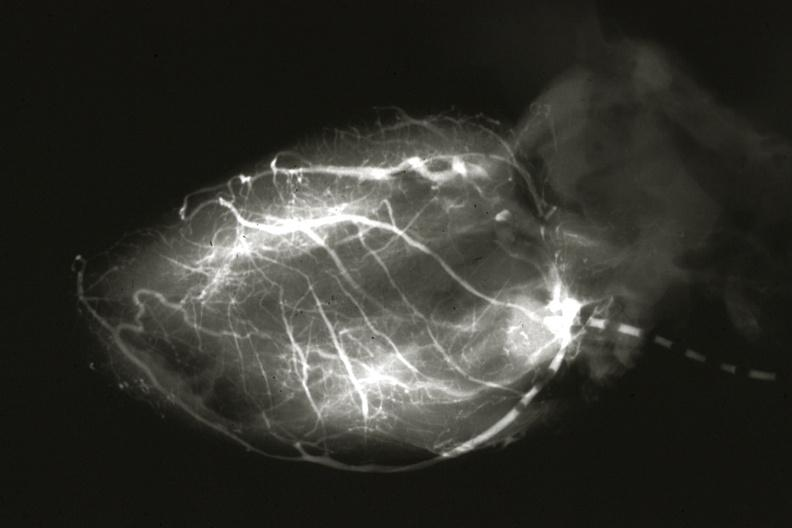s myocardium left from pulmonary artery?
Answer the question using a single word or phrase. No 